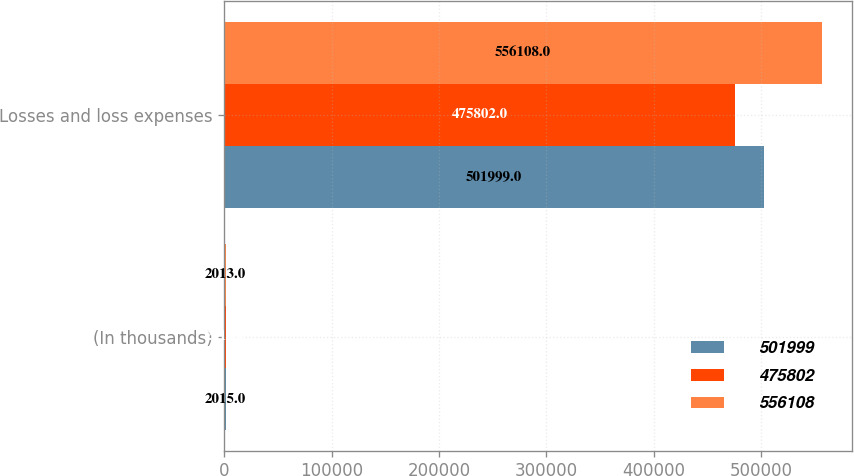Convert chart to OTSL. <chart><loc_0><loc_0><loc_500><loc_500><stacked_bar_chart><ecel><fcel>(In thousands)<fcel>Losses and loss expenses<nl><fcel>501999<fcel>2015<fcel>501999<nl><fcel>475802<fcel>2014<fcel>475802<nl><fcel>556108<fcel>2013<fcel>556108<nl></chart> 